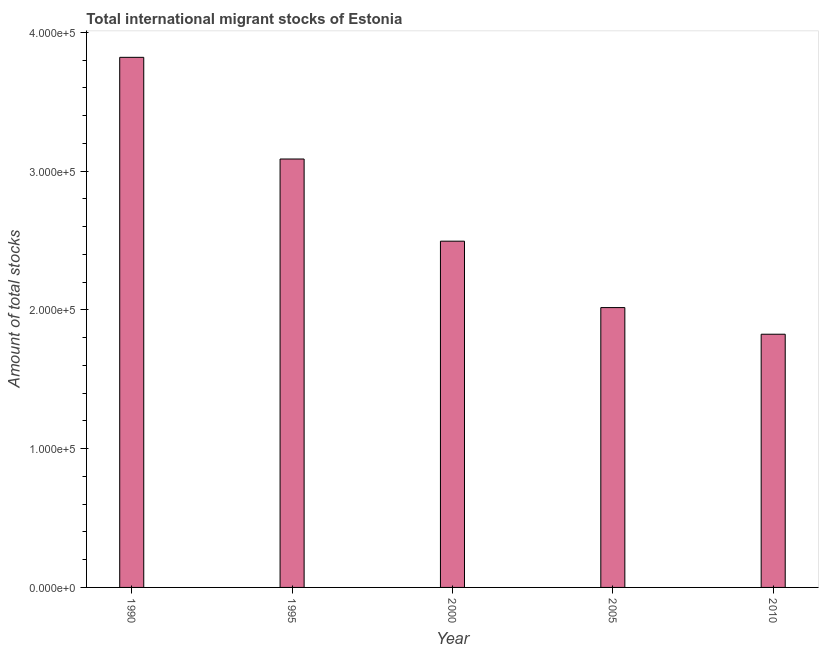Does the graph contain any zero values?
Make the answer very short. No. What is the title of the graph?
Give a very brief answer. Total international migrant stocks of Estonia. What is the label or title of the Y-axis?
Keep it short and to the point. Amount of total stocks. What is the total number of international migrant stock in 1995?
Your response must be concise. 3.09e+05. Across all years, what is the maximum total number of international migrant stock?
Your response must be concise. 3.82e+05. Across all years, what is the minimum total number of international migrant stock?
Your response must be concise. 1.82e+05. In which year was the total number of international migrant stock maximum?
Offer a very short reply. 1990. What is the sum of the total number of international migrant stock?
Keep it short and to the point. 1.32e+06. What is the difference between the total number of international migrant stock in 2005 and 2010?
Provide a succinct answer. 1.92e+04. What is the average total number of international migrant stock per year?
Make the answer very short. 2.65e+05. What is the median total number of international migrant stock?
Your answer should be compact. 2.50e+05. Do a majority of the years between 1990 and 1995 (inclusive) have total number of international migrant stock greater than 100000 ?
Give a very brief answer. Yes. What is the ratio of the total number of international migrant stock in 1995 to that in 2000?
Ensure brevity in your answer.  1.24. Is the total number of international migrant stock in 2000 less than that in 2010?
Your response must be concise. No. Is the difference between the total number of international migrant stock in 1990 and 1995 greater than the difference between any two years?
Your response must be concise. No. What is the difference between the highest and the second highest total number of international migrant stock?
Ensure brevity in your answer.  7.33e+04. Is the sum of the total number of international migrant stock in 1990 and 2000 greater than the maximum total number of international migrant stock across all years?
Ensure brevity in your answer.  Yes. What is the difference between the highest and the lowest total number of international migrant stock?
Keep it short and to the point. 2.00e+05. How many years are there in the graph?
Your answer should be compact. 5. Are the values on the major ticks of Y-axis written in scientific E-notation?
Keep it short and to the point. Yes. What is the Amount of total stocks of 1990?
Keep it short and to the point. 3.82e+05. What is the Amount of total stocks in 1995?
Keep it short and to the point. 3.09e+05. What is the Amount of total stocks in 2000?
Offer a very short reply. 2.50e+05. What is the Amount of total stocks of 2005?
Ensure brevity in your answer.  2.02e+05. What is the Amount of total stocks of 2010?
Provide a succinct answer. 1.82e+05. What is the difference between the Amount of total stocks in 1990 and 1995?
Make the answer very short. 7.33e+04. What is the difference between the Amount of total stocks in 1990 and 2000?
Offer a very short reply. 1.32e+05. What is the difference between the Amount of total stocks in 1990 and 2005?
Ensure brevity in your answer.  1.80e+05. What is the difference between the Amount of total stocks in 1990 and 2010?
Keep it short and to the point. 2.00e+05. What is the difference between the Amount of total stocks in 1995 and 2000?
Provide a succinct answer. 5.92e+04. What is the difference between the Amount of total stocks in 1995 and 2005?
Keep it short and to the point. 1.07e+05. What is the difference between the Amount of total stocks in 1995 and 2010?
Ensure brevity in your answer.  1.26e+05. What is the difference between the Amount of total stocks in 2000 and 2005?
Offer a very short reply. 4.79e+04. What is the difference between the Amount of total stocks in 2000 and 2010?
Make the answer very short. 6.70e+04. What is the difference between the Amount of total stocks in 2005 and 2010?
Make the answer very short. 1.92e+04. What is the ratio of the Amount of total stocks in 1990 to that in 1995?
Offer a terse response. 1.24. What is the ratio of the Amount of total stocks in 1990 to that in 2000?
Your answer should be compact. 1.53. What is the ratio of the Amount of total stocks in 1990 to that in 2005?
Provide a succinct answer. 1.89. What is the ratio of the Amount of total stocks in 1990 to that in 2010?
Your answer should be very brief. 2.09. What is the ratio of the Amount of total stocks in 1995 to that in 2000?
Your response must be concise. 1.24. What is the ratio of the Amount of total stocks in 1995 to that in 2005?
Offer a very short reply. 1.53. What is the ratio of the Amount of total stocks in 1995 to that in 2010?
Give a very brief answer. 1.69. What is the ratio of the Amount of total stocks in 2000 to that in 2005?
Your answer should be compact. 1.24. What is the ratio of the Amount of total stocks in 2000 to that in 2010?
Give a very brief answer. 1.37. What is the ratio of the Amount of total stocks in 2005 to that in 2010?
Provide a short and direct response. 1.1. 